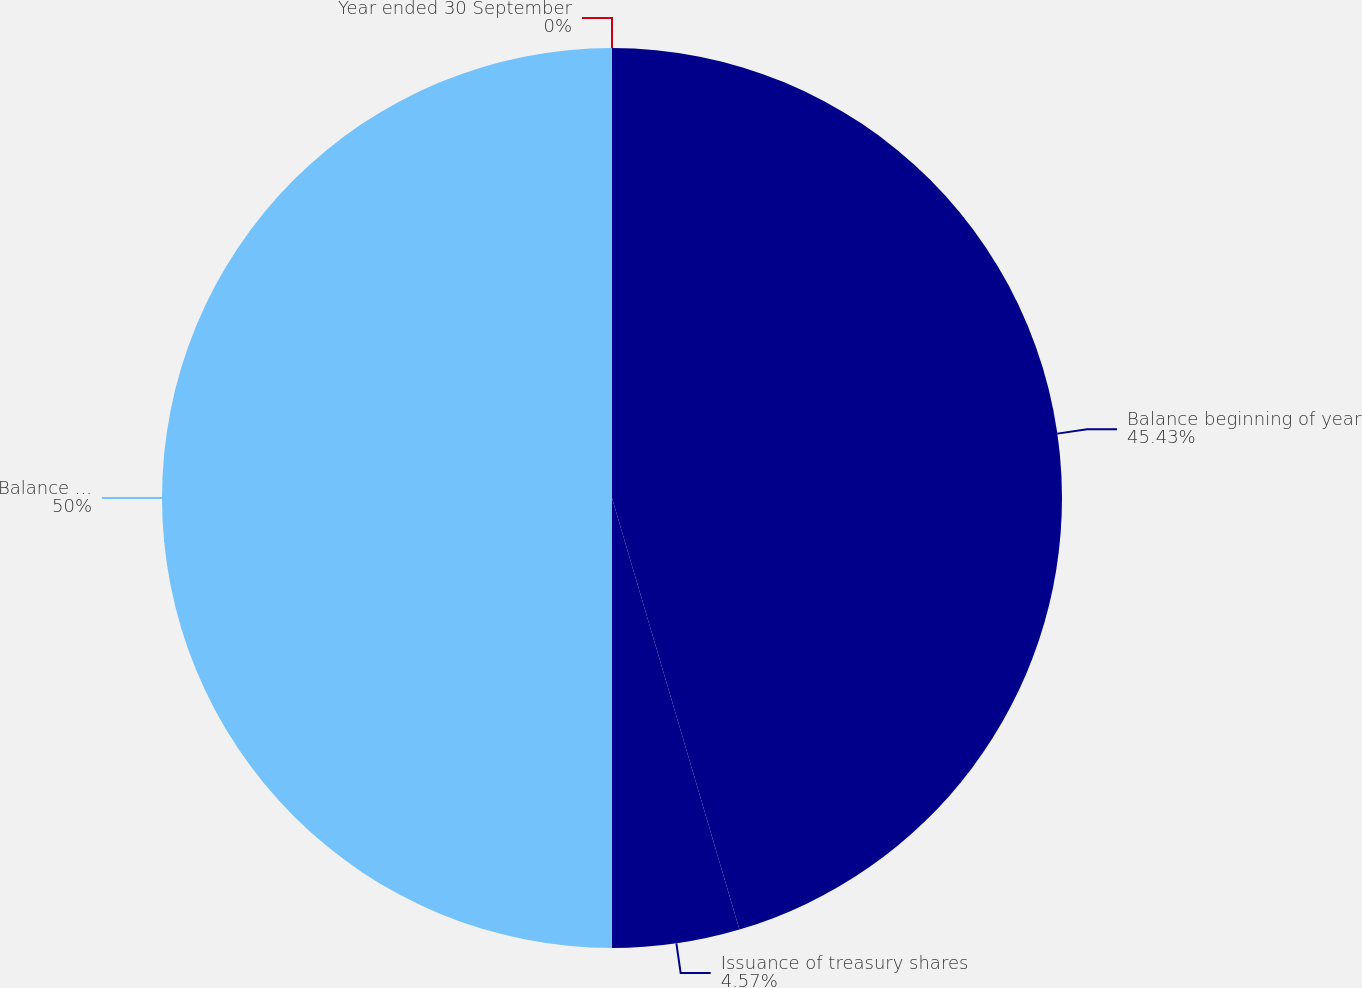Convert chart. <chart><loc_0><loc_0><loc_500><loc_500><pie_chart><fcel>Year ended 30 September<fcel>Balance beginning of year<fcel>Issuance of treasury shares<fcel>Balance end of year<nl><fcel>0.0%<fcel>45.43%<fcel>4.57%<fcel>50.0%<nl></chart> 